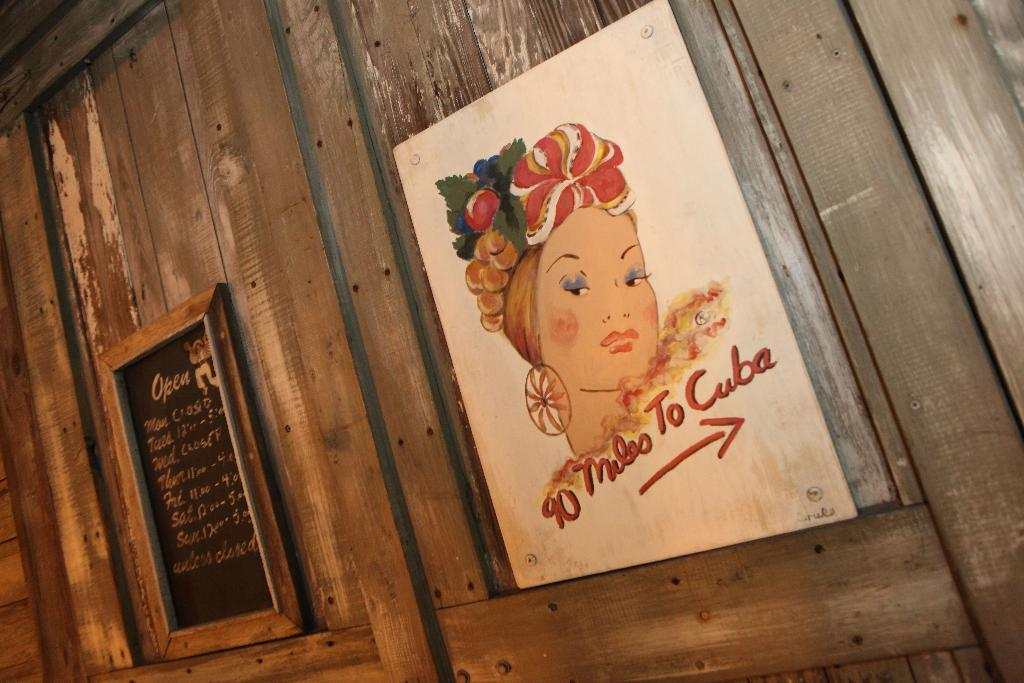<image>
Present a compact description of the photo's key features. A painting of a woman is hanging on the wall with the words 90 miles to Cuba on the bottom. 